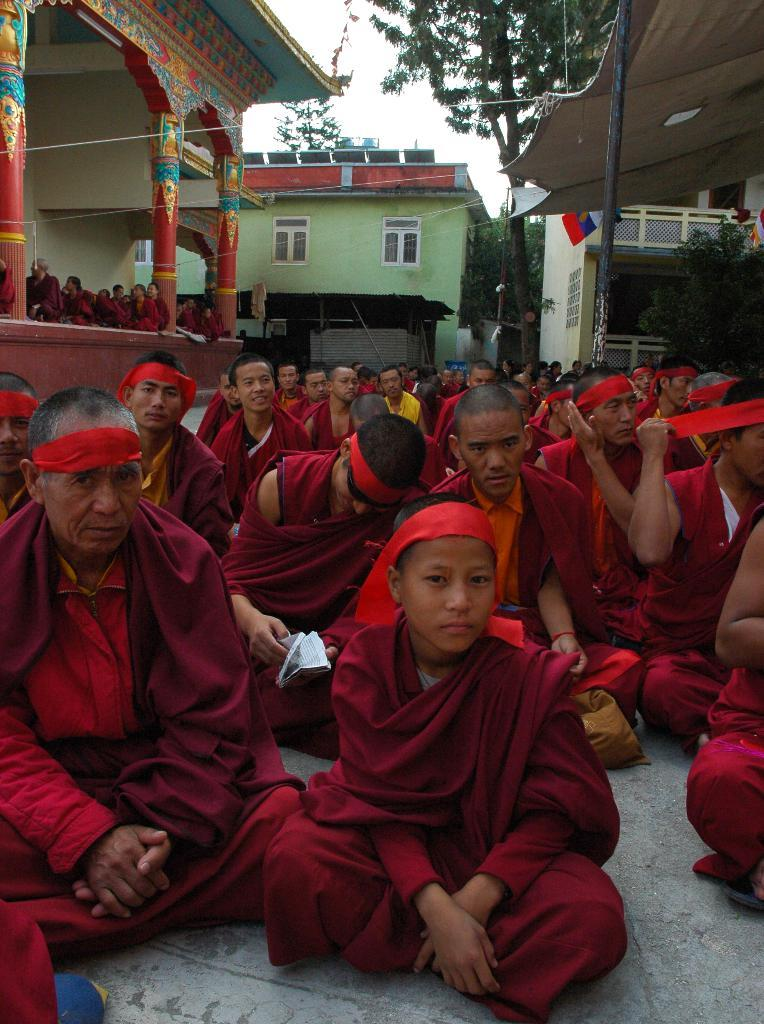How many people are in the image? There is a group of people in the image. What are some of the people in the image doing? Some people are sitting on the ground, while others are standing. What can be seen in the background of the image? There are buildings with windows, trees, and the sky visible in the background. What type of shock can be seen affecting the people in the image? There is no shock present in the image; the people are simply sitting or standing. Can you tell me how many rats are visible in the image? There are no rats present in the image. 